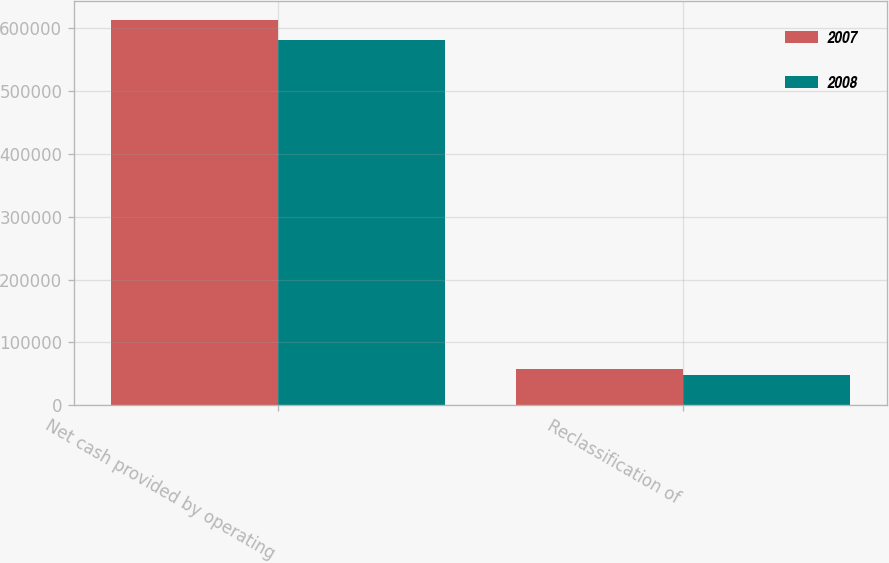Convert chart. <chart><loc_0><loc_0><loc_500><loc_500><stacked_bar_chart><ecel><fcel>Net cash provided by operating<fcel>Reclassification of<nl><fcel>2007<fcel>613701<fcel>57770<nl><fcel>2008<fcel>581065<fcel>48029<nl></chart> 